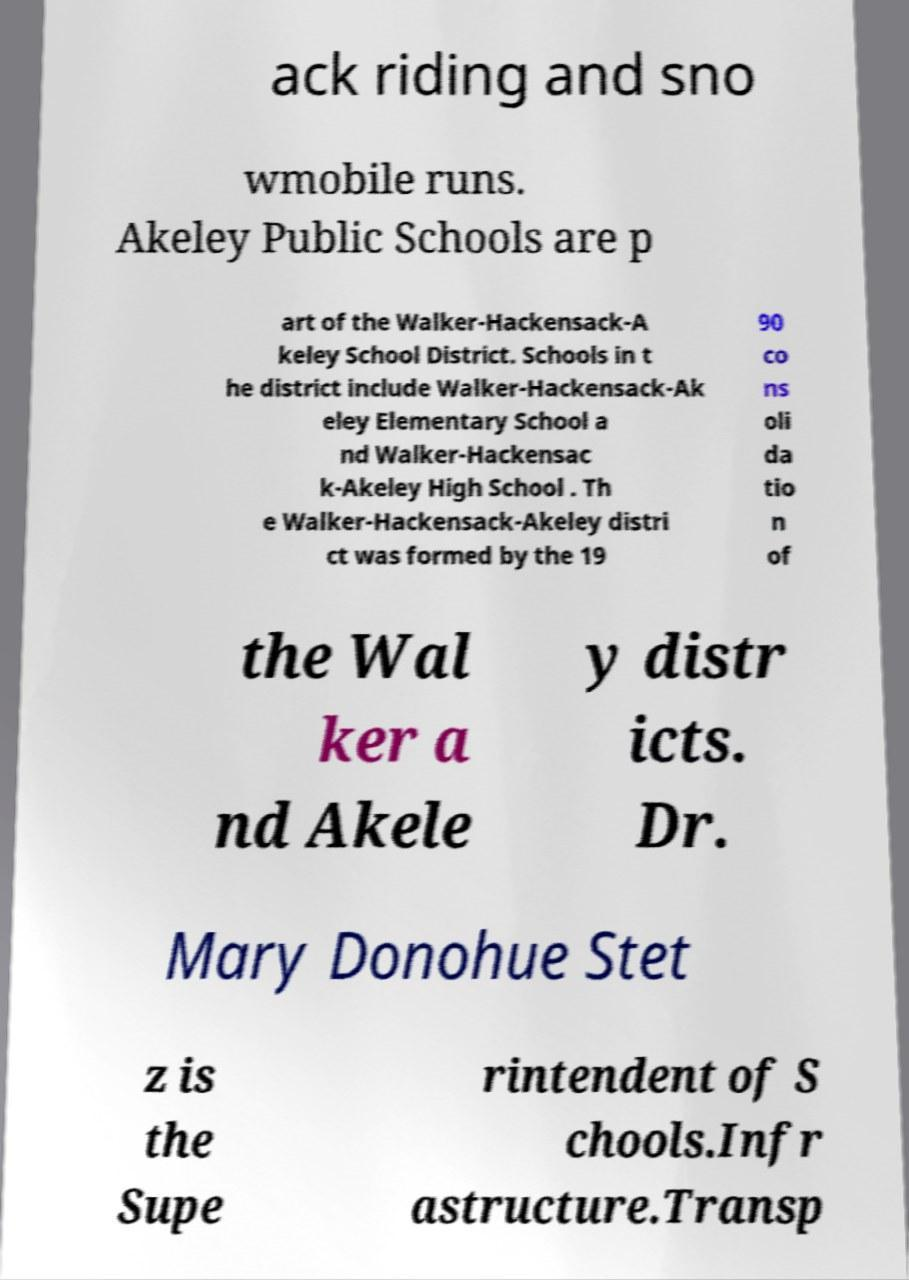Please read and relay the text visible in this image. What does it say? ack riding and sno wmobile runs. Akeley Public Schools are p art of the Walker-Hackensack-A keley School District. Schools in t he district include Walker-Hackensack-Ak eley Elementary School a nd Walker-Hackensac k-Akeley High School . Th e Walker-Hackensack-Akeley distri ct was formed by the 19 90 co ns oli da tio n of the Wal ker a nd Akele y distr icts. Dr. Mary Donohue Stet z is the Supe rintendent of S chools.Infr astructure.Transp 